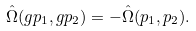Convert formula to latex. <formula><loc_0><loc_0><loc_500><loc_500>\hat { \Omega } ( g p _ { 1 } , g p _ { 2 } ) = - \hat { \Omega } ( p _ { 1 } , p _ { 2 } ) .</formula> 